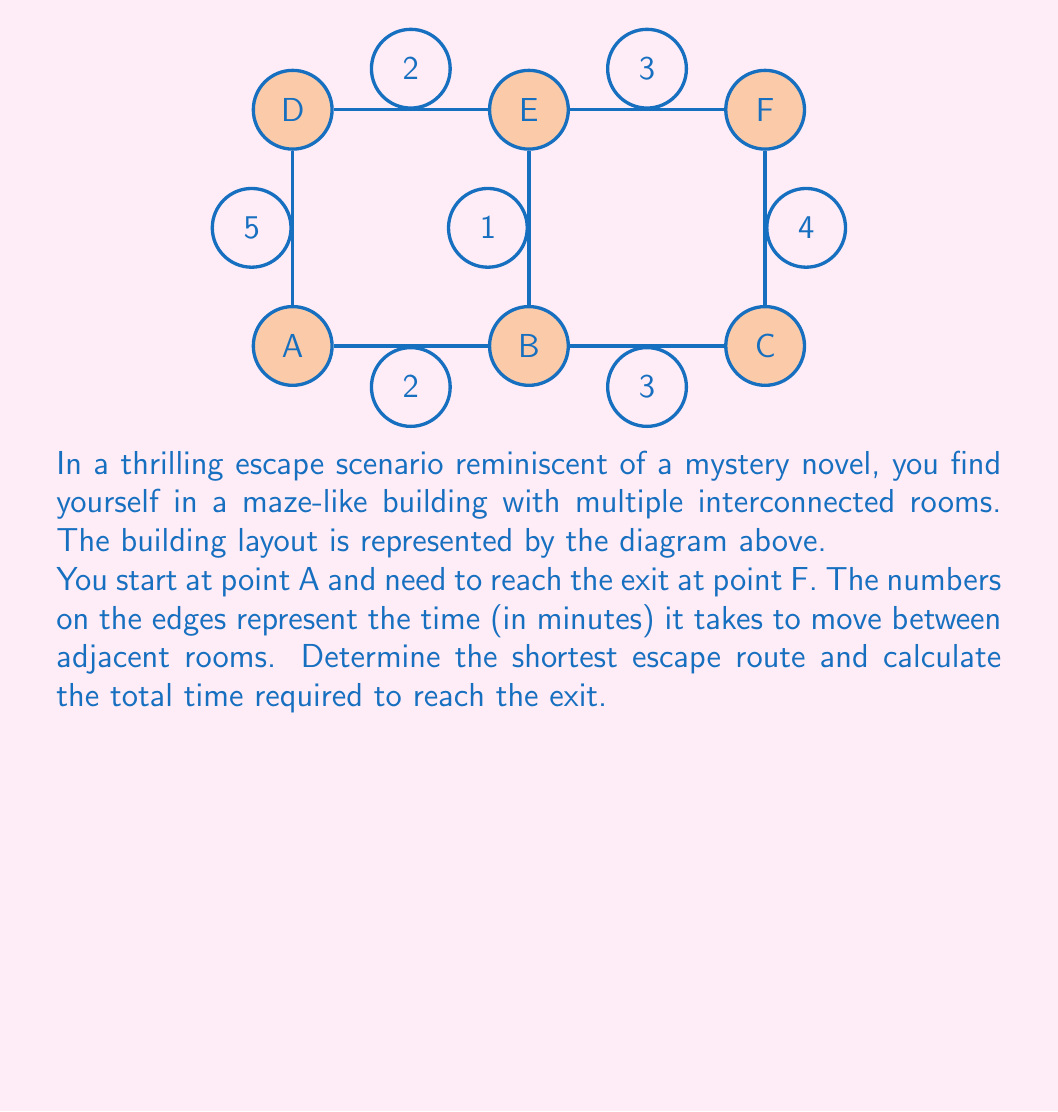Can you answer this question? A → B → E → F, 6 minutes 